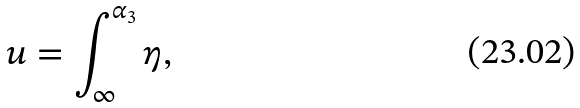Convert formula to latex. <formula><loc_0><loc_0><loc_500><loc_500>u = \int _ { \infty } ^ { \alpha _ { 3 } } \eta ,</formula> 